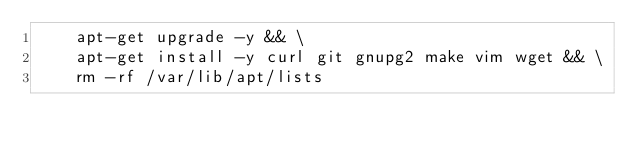<code> <loc_0><loc_0><loc_500><loc_500><_Dockerfile_>    apt-get upgrade -y && \
    apt-get install -y curl git gnupg2 make vim wget && \
    rm -rf /var/lib/apt/lists
</code> 